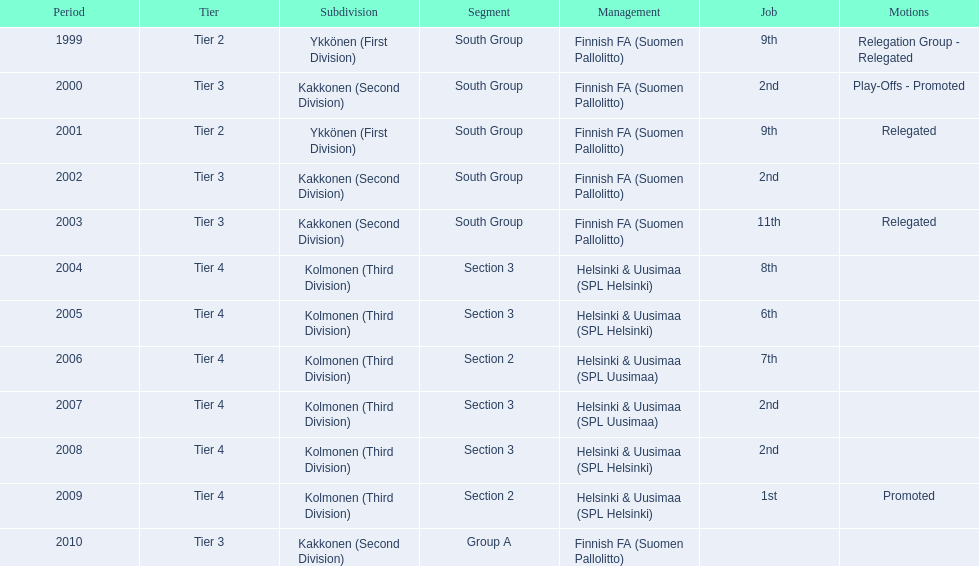When was the last year they placed 2nd? 2008. 